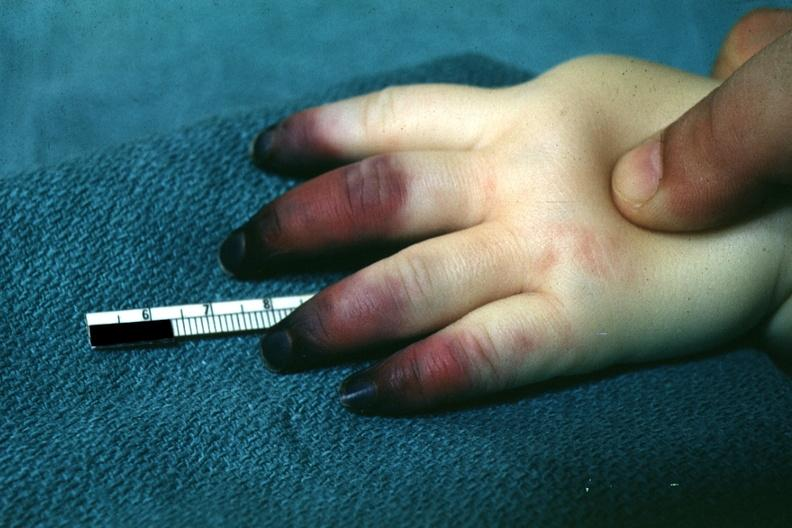does this image show outstandingly horrible example in infant with apparent gangrene of distal and middle phalanges pseudomonas sepsis?
Answer the question using a single word or phrase. Yes 